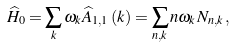Convert formula to latex. <formula><loc_0><loc_0><loc_500><loc_500>\widehat { H } _ { 0 } = \sum _ { k } \omega _ { k } \widehat { A } _ { 1 , 1 } \left ( k \right ) = \sum _ { n , k } n \omega _ { k } N _ { n , k } \, ,</formula> 